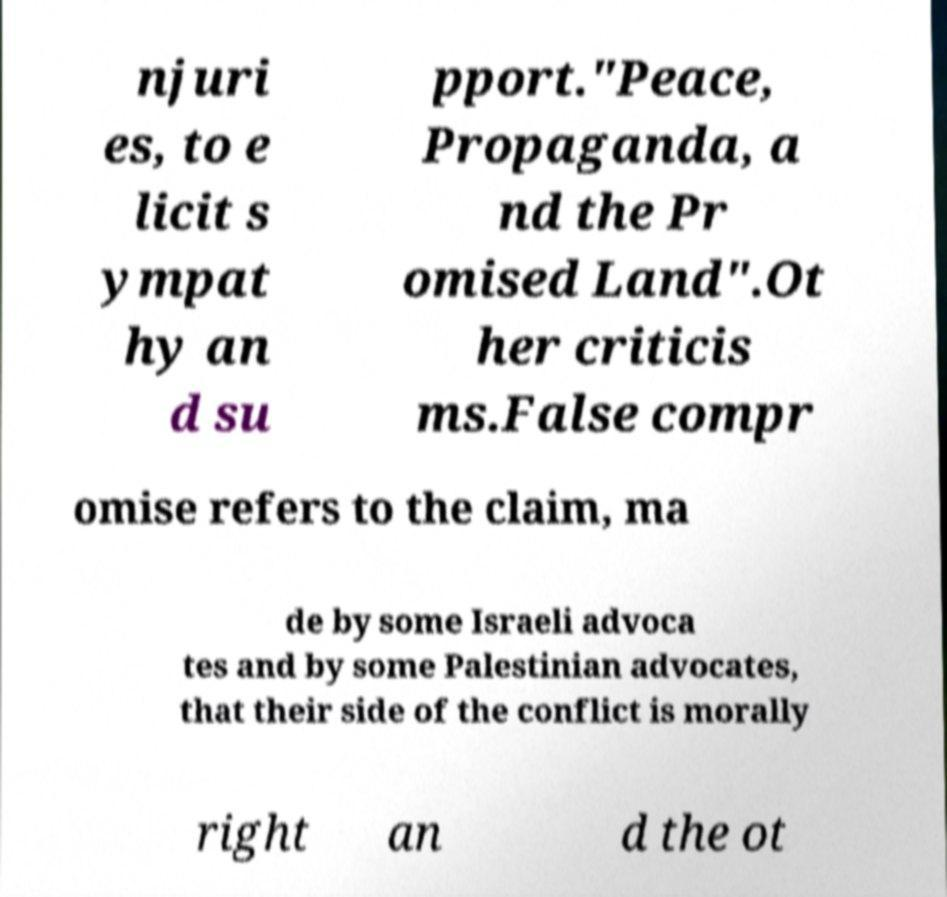Please identify and transcribe the text found in this image. njuri es, to e licit s ympat hy an d su pport."Peace, Propaganda, a nd the Pr omised Land".Ot her criticis ms.False compr omise refers to the claim, ma de by some Israeli advoca tes and by some Palestinian advocates, that their side of the conflict is morally right an d the ot 